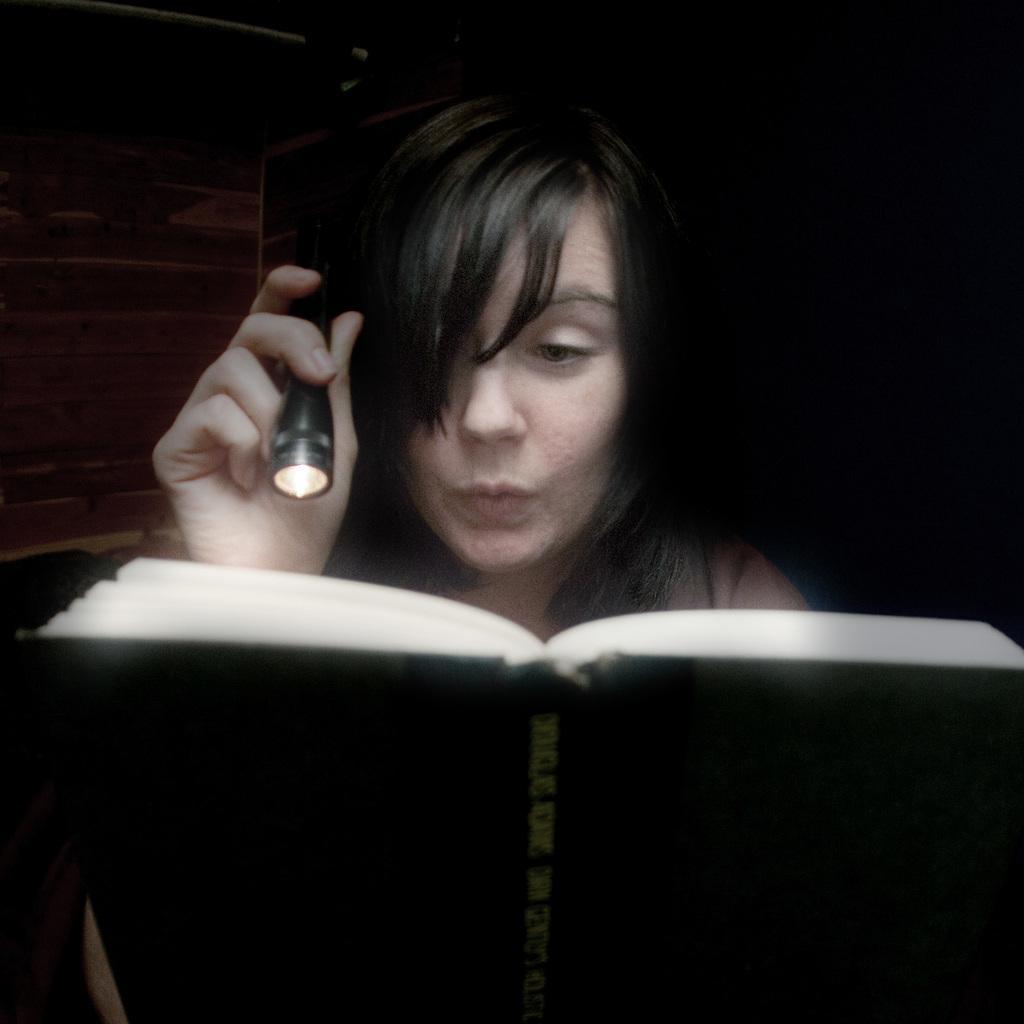Could you give a brief overview of what you see in this image? In this picture we can observe a woman holding a book and a torch. The background is completely dark. 